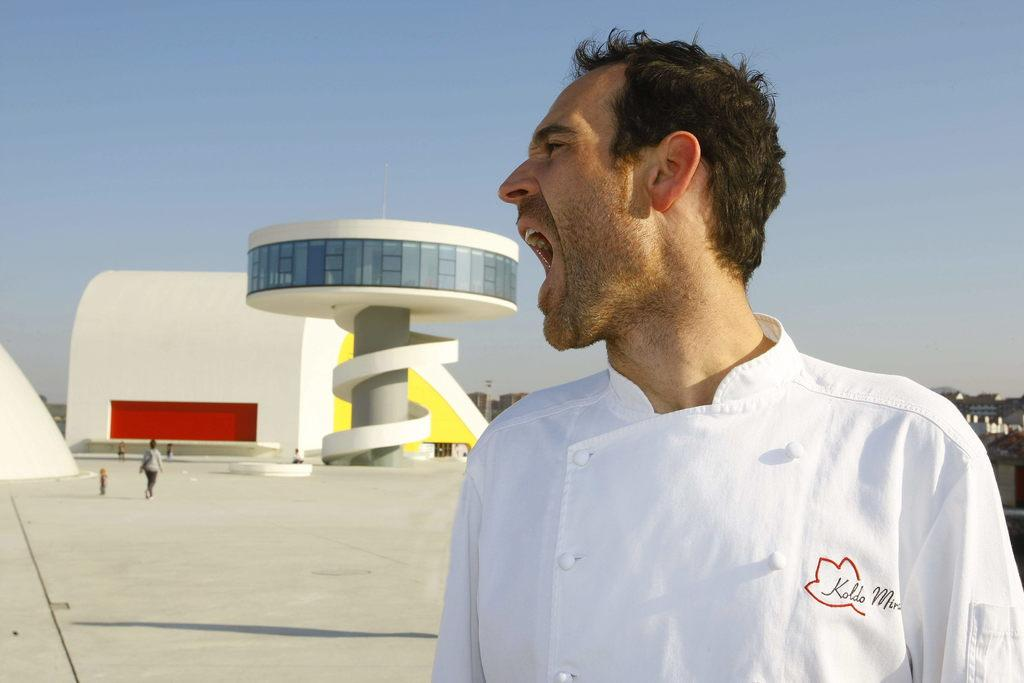What is the person in the foreground of the image doing? The person is opening his mouth in the image. What is the person in the background of the image doing? The person in the background is walking in the image. What can be seen in the distance in the image? There are buildings in the background of the image. What is visible at the top of the image? The sky is visible at the top of the image. What type of crate is being used to transport learning materials in the image? There is no crate or learning materials present in the image. 